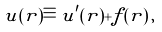<formula> <loc_0><loc_0><loc_500><loc_500>u ( { r } ) \equiv u ^ { \prime } ( { r } ) + f ( { r } ) \, ,</formula> 